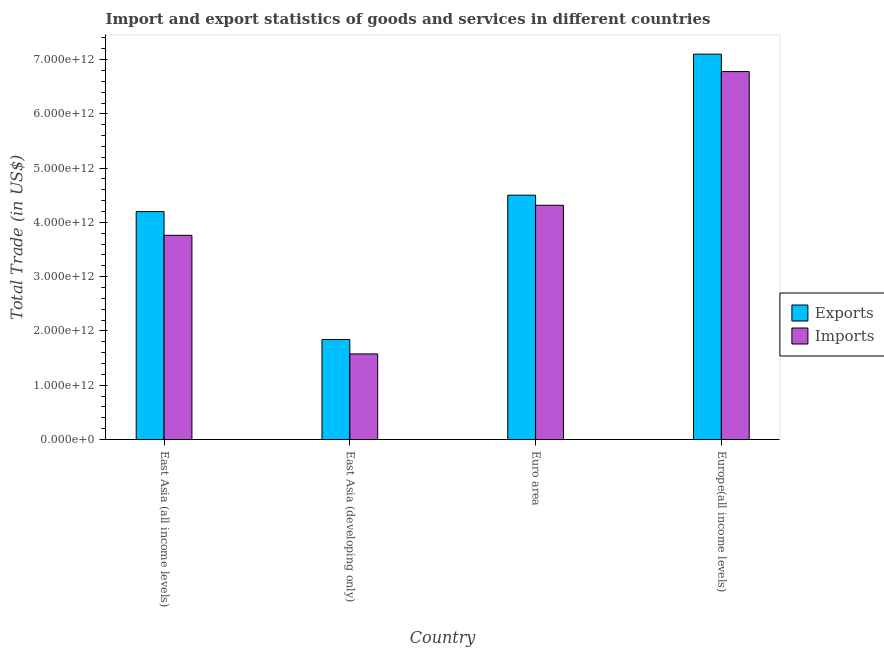How many groups of bars are there?
Provide a succinct answer. 4. Are the number of bars on each tick of the X-axis equal?
Your answer should be very brief. Yes. How many bars are there on the 1st tick from the right?
Provide a short and direct response. 2. In how many cases, is the number of bars for a given country not equal to the number of legend labels?
Ensure brevity in your answer.  0. What is the export of goods and services in East Asia (all income levels)?
Your response must be concise. 4.20e+12. Across all countries, what is the maximum imports of goods and services?
Your answer should be compact. 6.78e+12. Across all countries, what is the minimum export of goods and services?
Keep it short and to the point. 1.84e+12. In which country was the imports of goods and services maximum?
Your response must be concise. Europe(all income levels). In which country was the export of goods and services minimum?
Ensure brevity in your answer.  East Asia (developing only). What is the total imports of goods and services in the graph?
Provide a short and direct response. 1.64e+13. What is the difference between the export of goods and services in East Asia (all income levels) and that in Euro area?
Offer a very short reply. -3.02e+11. What is the difference between the export of goods and services in East Asia (all income levels) and the imports of goods and services in Europe(all income levels)?
Your answer should be very brief. -2.58e+12. What is the average imports of goods and services per country?
Your answer should be very brief. 4.11e+12. What is the difference between the export of goods and services and imports of goods and services in Europe(all income levels)?
Keep it short and to the point. 3.21e+11. What is the ratio of the export of goods and services in East Asia (developing only) to that in Euro area?
Provide a short and direct response. 0.41. Is the export of goods and services in East Asia (developing only) less than that in Euro area?
Make the answer very short. Yes. Is the difference between the export of goods and services in East Asia (developing only) and Euro area greater than the difference between the imports of goods and services in East Asia (developing only) and Euro area?
Give a very brief answer. Yes. What is the difference between the highest and the second highest imports of goods and services?
Make the answer very short. 2.46e+12. What is the difference between the highest and the lowest export of goods and services?
Your answer should be compact. 5.26e+12. What does the 2nd bar from the left in East Asia (all income levels) represents?
Keep it short and to the point. Imports. What does the 1st bar from the right in Europe(all income levels) represents?
Offer a very short reply. Imports. How many bars are there?
Provide a succinct answer. 8. Are all the bars in the graph horizontal?
Provide a succinct answer. No. How many countries are there in the graph?
Your answer should be compact. 4. What is the difference between two consecutive major ticks on the Y-axis?
Provide a short and direct response. 1.00e+12. Does the graph contain grids?
Offer a very short reply. No. Where does the legend appear in the graph?
Ensure brevity in your answer.  Center right. How many legend labels are there?
Provide a succinct answer. 2. What is the title of the graph?
Your answer should be very brief. Import and export statistics of goods and services in different countries. Does "Lowest 20% of population" appear as one of the legend labels in the graph?
Your response must be concise. No. What is the label or title of the X-axis?
Make the answer very short. Country. What is the label or title of the Y-axis?
Your answer should be very brief. Total Trade (in US$). What is the Total Trade (in US$) in Exports in East Asia (all income levels)?
Ensure brevity in your answer.  4.20e+12. What is the Total Trade (in US$) in Imports in East Asia (all income levels)?
Your answer should be very brief. 3.76e+12. What is the Total Trade (in US$) of Exports in East Asia (developing only)?
Your answer should be very brief. 1.84e+12. What is the Total Trade (in US$) of Imports in East Asia (developing only)?
Offer a terse response. 1.58e+12. What is the Total Trade (in US$) in Exports in Euro area?
Offer a very short reply. 4.50e+12. What is the Total Trade (in US$) of Imports in Euro area?
Provide a short and direct response. 4.32e+12. What is the Total Trade (in US$) in Exports in Europe(all income levels)?
Offer a terse response. 7.10e+12. What is the Total Trade (in US$) in Imports in Europe(all income levels)?
Your answer should be very brief. 6.78e+12. Across all countries, what is the maximum Total Trade (in US$) in Exports?
Make the answer very short. 7.10e+12. Across all countries, what is the maximum Total Trade (in US$) in Imports?
Give a very brief answer. 6.78e+12. Across all countries, what is the minimum Total Trade (in US$) of Exports?
Offer a terse response. 1.84e+12. Across all countries, what is the minimum Total Trade (in US$) of Imports?
Your answer should be very brief. 1.58e+12. What is the total Total Trade (in US$) of Exports in the graph?
Your answer should be compact. 1.76e+13. What is the total Total Trade (in US$) of Imports in the graph?
Keep it short and to the point. 1.64e+13. What is the difference between the Total Trade (in US$) of Exports in East Asia (all income levels) and that in East Asia (developing only)?
Provide a succinct answer. 2.36e+12. What is the difference between the Total Trade (in US$) of Imports in East Asia (all income levels) and that in East Asia (developing only)?
Provide a succinct answer. 2.19e+12. What is the difference between the Total Trade (in US$) of Exports in East Asia (all income levels) and that in Euro area?
Your answer should be very brief. -3.02e+11. What is the difference between the Total Trade (in US$) in Imports in East Asia (all income levels) and that in Euro area?
Give a very brief answer. -5.53e+11. What is the difference between the Total Trade (in US$) of Exports in East Asia (all income levels) and that in Europe(all income levels)?
Give a very brief answer. -2.90e+12. What is the difference between the Total Trade (in US$) in Imports in East Asia (all income levels) and that in Europe(all income levels)?
Give a very brief answer. -3.02e+12. What is the difference between the Total Trade (in US$) of Exports in East Asia (developing only) and that in Euro area?
Your answer should be very brief. -2.66e+12. What is the difference between the Total Trade (in US$) of Imports in East Asia (developing only) and that in Euro area?
Provide a short and direct response. -2.74e+12. What is the difference between the Total Trade (in US$) of Exports in East Asia (developing only) and that in Europe(all income levels)?
Your response must be concise. -5.26e+12. What is the difference between the Total Trade (in US$) in Imports in East Asia (developing only) and that in Europe(all income levels)?
Ensure brevity in your answer.  -5.20e+12. What is the difference between the Total Trade (in US$) in Exports in Euro area and that in Europe(all income levels)?
Provide a short and direct response. -2.60e+12. What is the difference between the Total Trade (in US$) in Imports in Euro area and that in Europe(all income levels)?
Your answer should be compact. -2.46e+12. What is the difference between the Total Trade (in US$) of Exports in East Asia (all income levels) and the Total Trade (in US$) of Imports in East Asia (developing only)?
Offer a very short reply. 2.62e+12. What is the difference between the Total Trade (in US$) of Exports in East Asia (all income levels) and the Total Trade (in US$) of Imports in Euro area?
Give a very brief answer. -1.16e+11. What is the difference between the Total Trade (in US$) in Exports in East Asia (all income levels) and the Total Trade (in US$) in Imports in Europe(all income levels)?
Offer a very short reply. -2.58e+12. What is the difference between the Total Trade (in US$) in Exports in East Asia (developing only) and the Total Trade (in US$) in Imports in Euro area?
Your response must be concise. -2.47e+12. What is the difference between the Total Trade (in US$) of Exports in East Asia (developing only) and the Total Trade (in US$) of Imports in Europe(all income levels)?
Provide a succinct answer. -4.94e+12. What is the difference between the Total Trade (in US$) of Exports in Euro area and the Total Trade (in US$) of Imports in Europe(all income levels)?
Provide a succinct answer. -2.28e+12. What is the average Total Trade (in US$) in Exports per country?
Give a very brief answer. 4.41e+12. What is the average Total Trade (in US$) in Imports per country?
Keep it short and to the point. 4.11e+12. What is the difference between the Total Trade (in US$) of Exports and Total Trade (in US$) of Imports in East Asia (all income levels)?
Your response must be concise. 4.37e+11. What is the difference between the Total Trade (in US$) of Exports and Total Trade (in US$) of Imports in East Asia (developing only)?
Make the answer very short. 2.66e+11. What is the difference between the Total Trade (in US$) in Exports and Total Trade (in US$) in Imports in Euro area?
Give a very brief answer. 1.86e+11. What is the difference between the Total Trade (in US$) in Exports and Total Trade (in US$) in Imports in Europe(all income levels)?
Offer a terse response. 3.21e+11. What is the ratio of the Total Trade (in US$) in Exports in East Asia (all income levels) to that in East Asia (developing only)?
Your answer should be very brief. 2.28. What is the ratio of the Total Trade (in US$) of Imports in East Asia (all income levels) to that in East Asia (developing only)?
Keep it short and to the point. 2.39. What is the ratio of the Total Trade (in US$) of Exports in East Asia (all income levels) to that in Euro area?
Your answer should be very brief. 0.93. What is the ratio of the Total Trade (in US$) in Imports in East Asia (all income levels) to that in Euro area?
Provide a succinct answer. 0.87. What is the ratio of the Total Trade (in US$) of Exports in East Asia (all income levels) to that in Europe(all income levels)?
Your answer should be very brief. 0.59. What is the ratio of the Total Trade (in US$) of Imports in East Asia (all income levels) to that in Europe(all income levels)?
Your answer should be very brief. 0.56. What is the ratio of the Total Trade (in US$) of Exports in East Asia (developing only) to that in Euro area?
Your response must be concise. 0.41. What is the ratio of the Total Trade (in US$) in Imports in East Asia (developing only) to that in Euro area?
Your response must be concise. 0.37. What is the ratio of the Total Trade (in US$) of Exports in East Asia (developing only) to that in Europe(all income levels)?
Provide a succinct answer. 0.26. What is the ratio of the Total Trade (in US$) of Imports in East Asia (developing only) to that in Europe(all income levels)?
Make the answer very short. 0.23. What is the ratio of the Total Trade (in US$) of Exports in Euro area to that in Europe(all income levels)?
Your response must be concise. 0.63. What is the ratio of the Total Trade (in US$) in Imports in Euro area to that in Europe(all income levels)?
Your answer should be very brief. 0.64. What is the difference between the highest and the second highest Total Trade (in US$) in Exports?
Your response must be concise. 2.60e+12. What is the difference between the highest and the second highest Total Trade (in US$) in Imports?
Offer a terse response. 2.46e+12. What is the difference between the highest and the lowest Total Trade (in US$) of Exports?
Your answer should be very brief. 5.26e+12. What is the difference between the highest and the lowest Total Trade (in US$) of Imports?
Your answer should be very brief. 5.20e+12. 